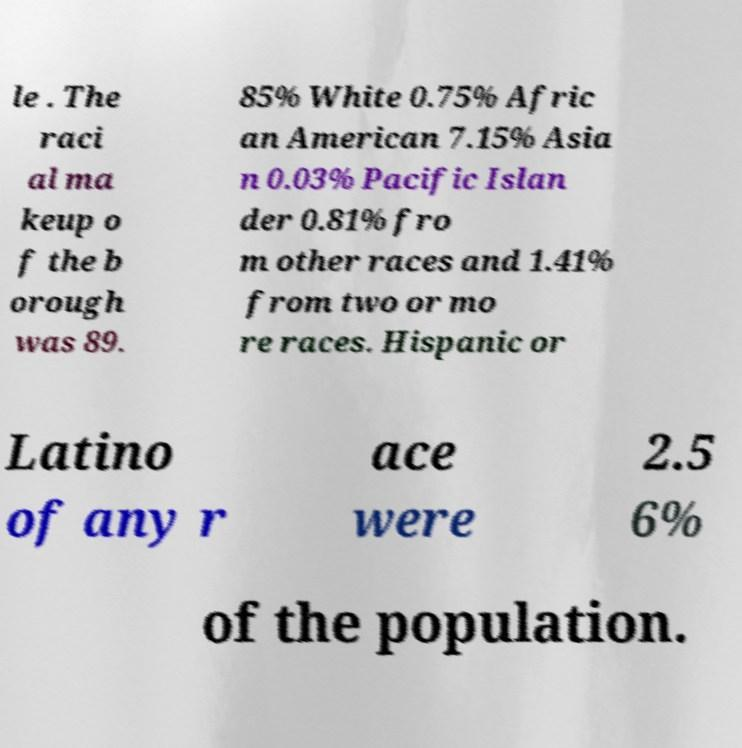There's text embedded in this image that I need extracted. Can you transcribe it verbatim? le . The raci al ma keup o f the b orough was 89. 85% White 0.75% Afric an American 7.15% Asia n 0.03% Pacific Islan der 0.81% fro m other races and 1.41% from two or mo re races. Hispanic or Latino of any r ace were 2.5 6% of the population. 